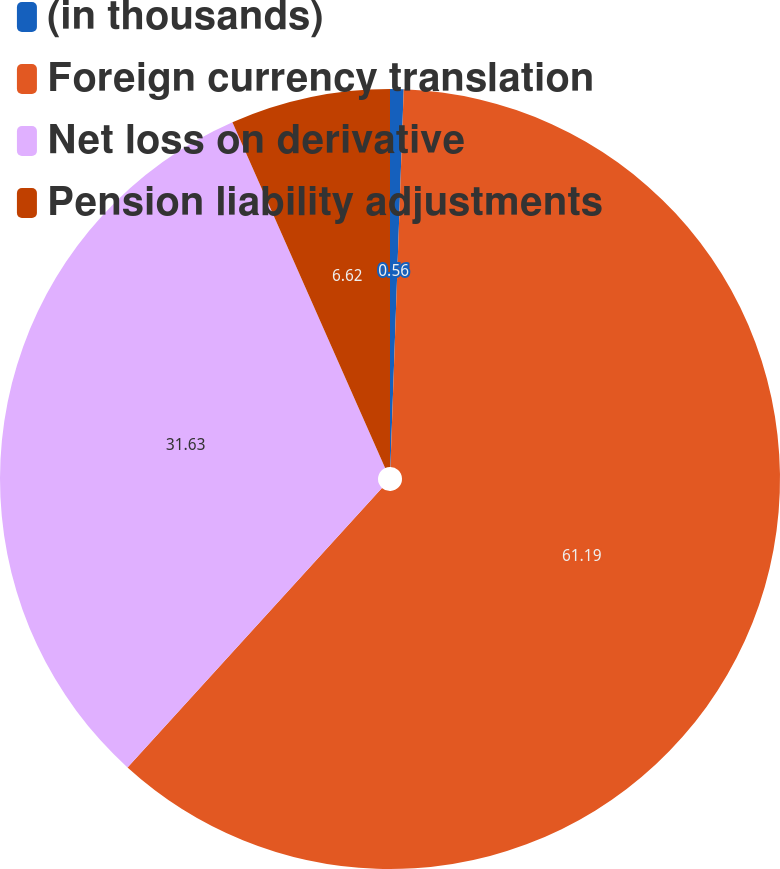<chart> <loc_0><loc_0><loc_500><loc_500><pie_chart><fcel>(in thousands)<fcel>Foreign currency translation<fcel>Net loss on derivative<fcel>Pension liability adjustments<nl><fcel>0.56%<fcel>61.19%<fcel>31.63%<fcel>6.62%<nl></chart> 